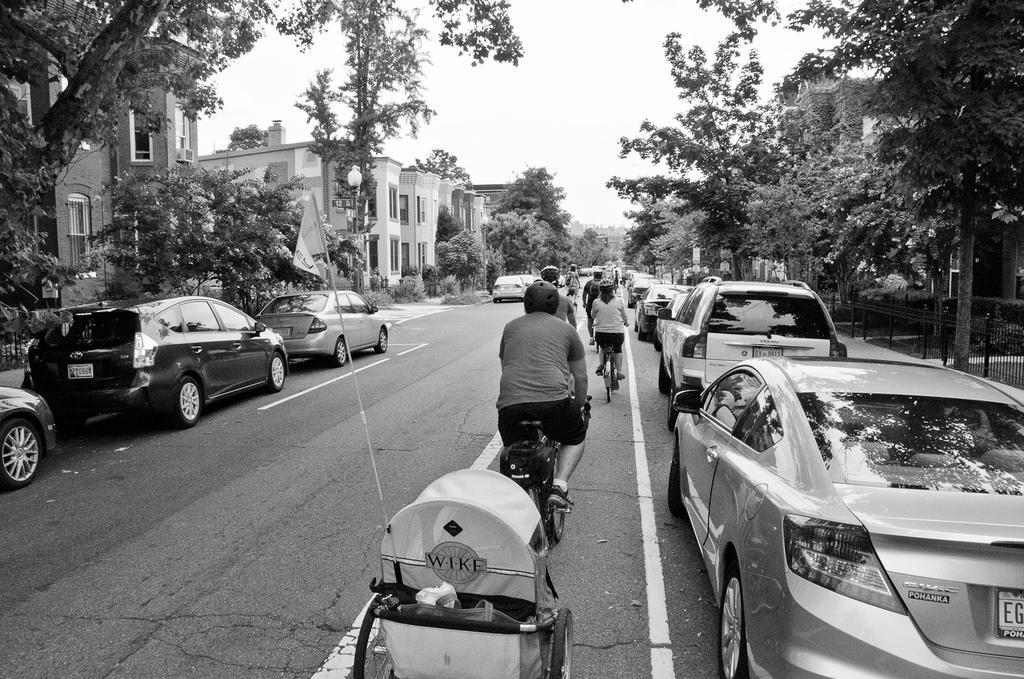Please provide a concise description of this image. This is a black and white image. In this image we can see persons riding bicycles on the road, baby pram, motor vehicles on the road, buildings, trees and sky. 